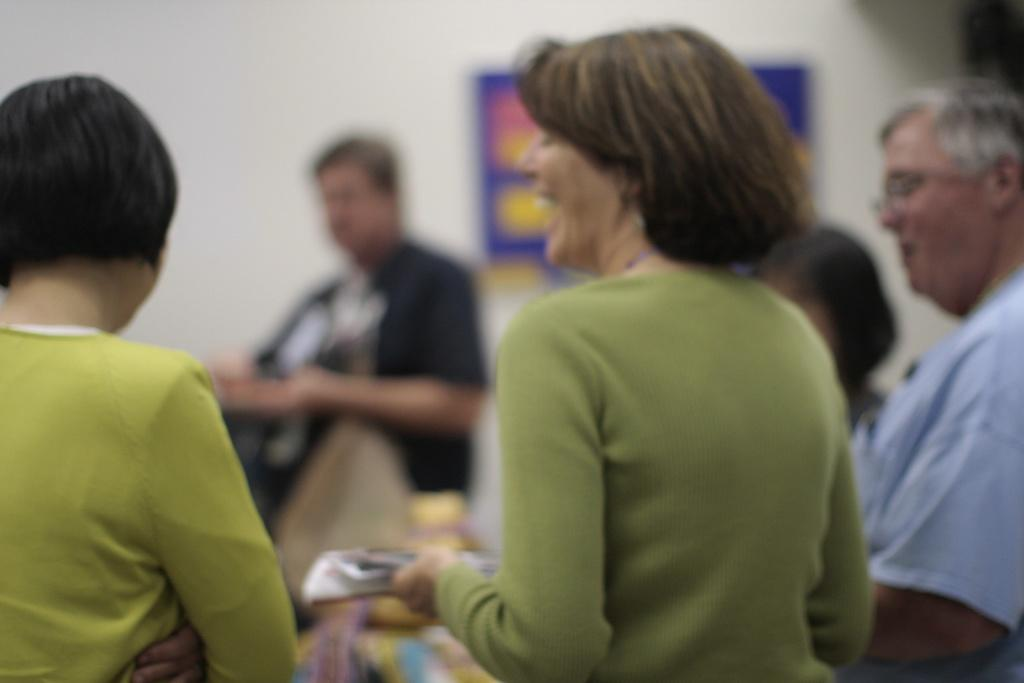What is happening in the image? There are people standing in the image. Can you describe what one person is holding? One person is holding something, but the image is blurred, so it's difficult to identify what it is. What can be seen in the background of the image? There is a wall visible in the image. What type of expert advice can be heard from the person holding something in the image? There is no indication in the image that the person holding something is an expert or providing any advice. Can you tell me how many kittens are in the person's pocket in the image? There is no person with a pocket or any kittens present in the image. 